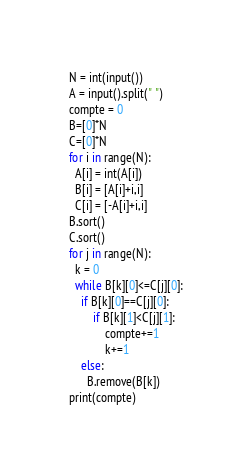<code> <loc_0><loc_0><loc_500><loc_500><_Python_>N = int(input())
A = input().split(" ")
compte = 0
B=[0]*N
C=[0]*N
for i in range(N):
  A[i] = int(A[i])
  B[i] = [A[i]+i,i]
  C[i] = [-A[i]+i,i]
B.sort()
C.sort()
for j in range(N):
  k = 0
  while B[k][0]<=C[j][0]:
    if B[k][0]==C[j][0]: 
    	if B[k][1]<C[j][1]:
      		compte+=1
      		k+=1
    else:
      B.remove(B[k])
print(compte)</code> 